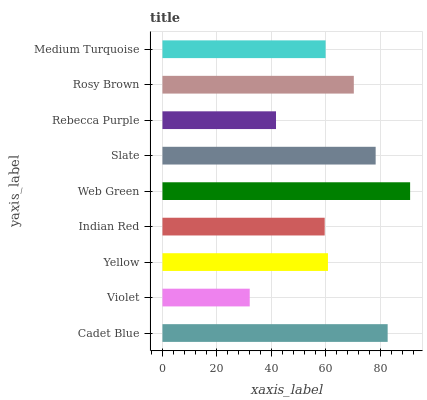Is Violet the minimum?
Answer yes or no. Yes. Is Web Green the maximum?
Answer yes or no. Yes. Is Yellow the minimum?
Answer yes or no. No. Is Yellow the maximum?
Answer yes or no. No. Is Yellow greater than Violet?
Answer yes or no. Yes. Is Violet less than Yellow?
Answer yes or no. Yes. Is Violet greater than Yellow?
Answer yes or no. No. Is Yellow less than Violet?
Answer yes or no. No. Is Yellow the high median?
Answer yes or no. Yes. Is Yellow the low median?
Answer yes or no. Yes. Is Cadet Blue the high median?
Answer yes or no. No. Is Violet the low median?
Answer yes or no. No. 